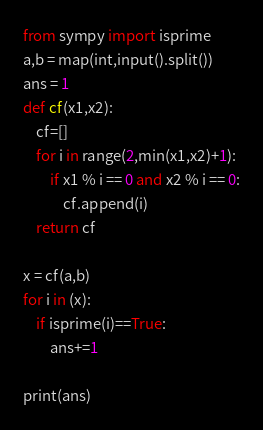Convert code to text. <code><loc_0><loc_0><loc_500><loc_500><_Python_>from sympy import isprime
a,b = map(int,input().split())
ans = 1
def cf(x1,x2):
    cf=[]
    for i in range(2,min(x1,x2)+1):
        if x1 % i == 0 and x2 % i == 0:
            cf.append(i)
    return cf

x = cf(a,b)
for i in (x):
    if isprime(i)==True:
        ans+=1

print(ans)</code> 